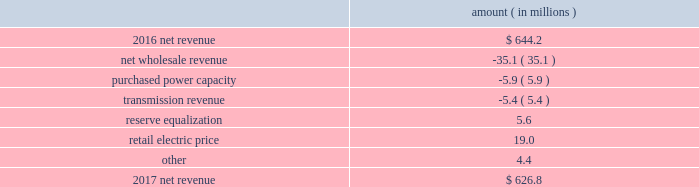Entergy texas , inc .
And subsidiaries management 2019s financial discussion and analysis results of operations net income 2017 compared to 2016 net income decreased $ 31.4 million primarily due to lower net revenue , higher depreciation and amortization expenses , higher other operation and maintenance expenses , and higher taxes other than income taxes .
2016 compared to 2015 net income increased $ 37.9 million primarily due to lower other operation and maintenance expenses , the asset write-off of its receivable associated with the spindletop gas storage facility in 2015 , and higher net revenue .
Net revenue 2017 compared to 2016 net revenue consists of operating revenues net of : 1 ) fuel , fuel-related expenses , and gas purchased for resale , 2 ) purchased power expenses , and 3 ) other regulatory charges .
Following is an analysis of the change in net revenue comparing 2017 to 2016 .
Amount ( in millions ) .
The net wholesale revenue variance is primarily due to lower net capacity revenues resulting from the termination of the purchased power agreements between entergy louisiana and entergy texas in august 2016 .
The purchased power capacity variance is primarily due to increased expenses due to capacity cost changes for ongoing purchased power capacity contracts .
The transmission revenue variance is primarily due to a decrease in the amount of transmission revenues allocated by miso .
The reserve equalization variance is due to the absence of reserve equalization expenses in 2017 as a result of entergy texas 2019s exit from the system agreement in august 2016 .
See note 2 to the financial statements for a discussion of the system agreement. .
What percent did net revenue decrease between 2016 and 2017? 
Computations: ((644.2 - 626.8) / 644.2)
Answer: 0.02701. 